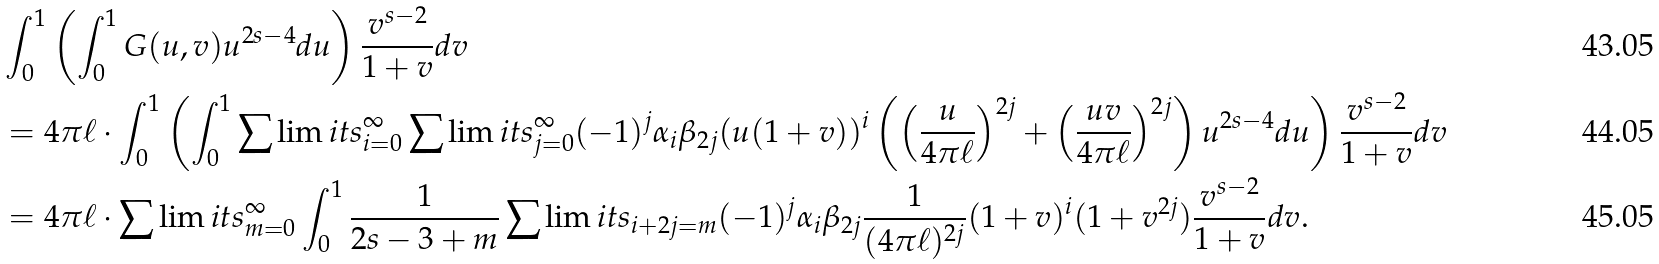Convert formula to latex. <formula><loc_0><loc_0><loc_500><loc_500>& \int _ { 0 } ^ { 1 } \left ( \int _ { 0 } ^ { 1 } G ( u , v ) u ^ { 2 s - 4 } d u \right ) \frac { v ^ { s - 2 } } { 1 + v } d v \\ & = 4 \pi \ell \cdot \int _ { 0 } ^ { 1 } \left ( \int _ { 0 } ^ { 1 } \sum \lim i t s _ { i = 0 } ^ { \infty } \sum \lim i t s _ { j = 0 } ^ { \infty } ( - 1 ) ^ { j } \alpha _ { i } \beta _ { 2 j } ( u ( 1 + v ) ) ^ { i } \left ( \left ( \frac { u } { 4 \pi { \ell } } \right ) ^ { 2 j } + \left ( \frac { u v } { 4 \pi { \ell } } \right ) ^ { 2 j } \right ) u ^ { 2 s - 4 } d u \right ) \frac { v ^ { s - 2 } } { 1 + v } d v \\ & = 4 \pi \ell \cdot \sum \lim i t s _ { m = 0 } ^ { \infty } \int _ { 0 } ^ { 1 } \frac { 1 } { 2 s - 3 + m } \sum \lim i t s _ { i + 2 j = m } ( - 1 ) ^ { j } \alpha _ { i } \beta _ { 2 j } \frac { 1 } { ( 4 \pi \ell ) ^ { 2 j } } ( 1 + v ) ^ { i } ( 1 + v ^ { 2 j } ) \frac { v ^ { s - 2 } } { 1 + v } d v .</formula> 